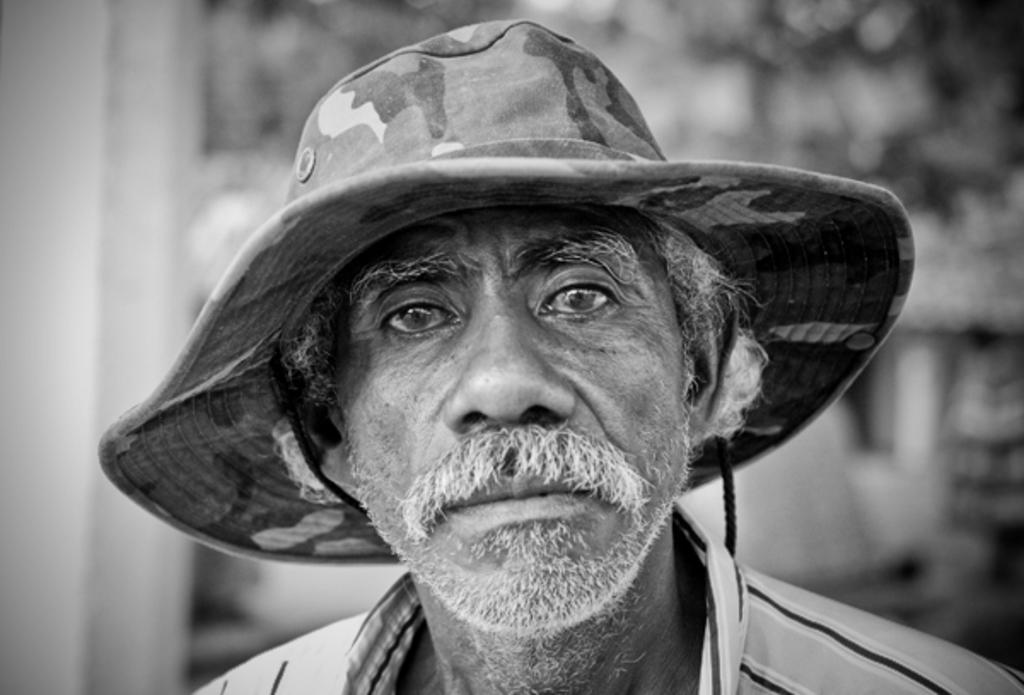Describe this image in one or two sentences. In this picture I can see a man in front who is wearing a hat on his head and I see that he is wearing shirt. I can also see that it is blurred in the background and I see that this is a black and white image. 